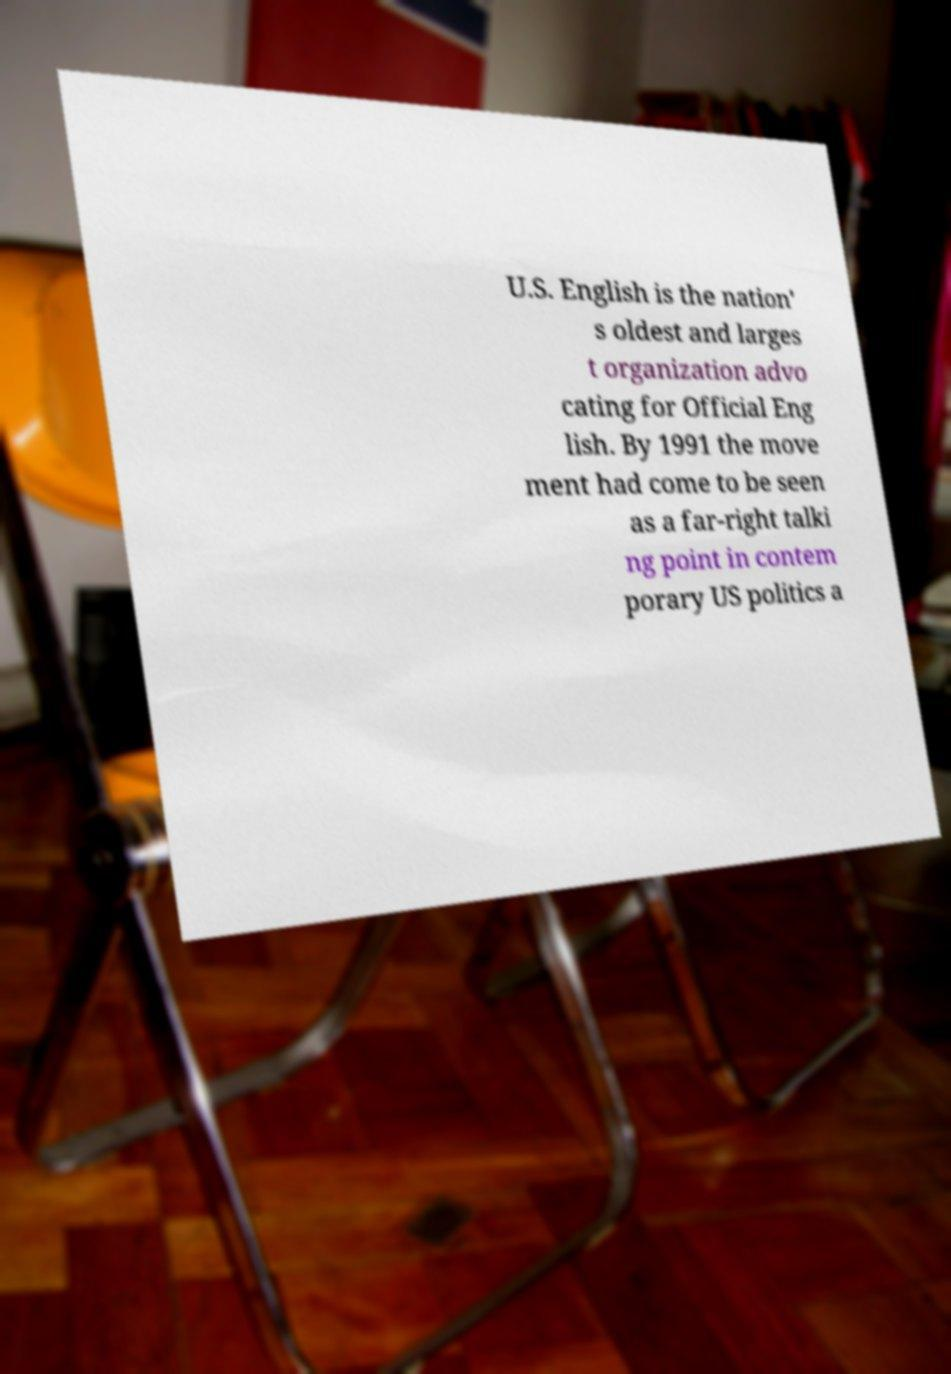Please read and relay the text visible in this image. What does it say? U.S. English is the nation' s oldest and larges t organization advo cating for Official Eng lish. By 1991 the move ment had come to be seen as a far-right talki ng point in contem porary US politics a 